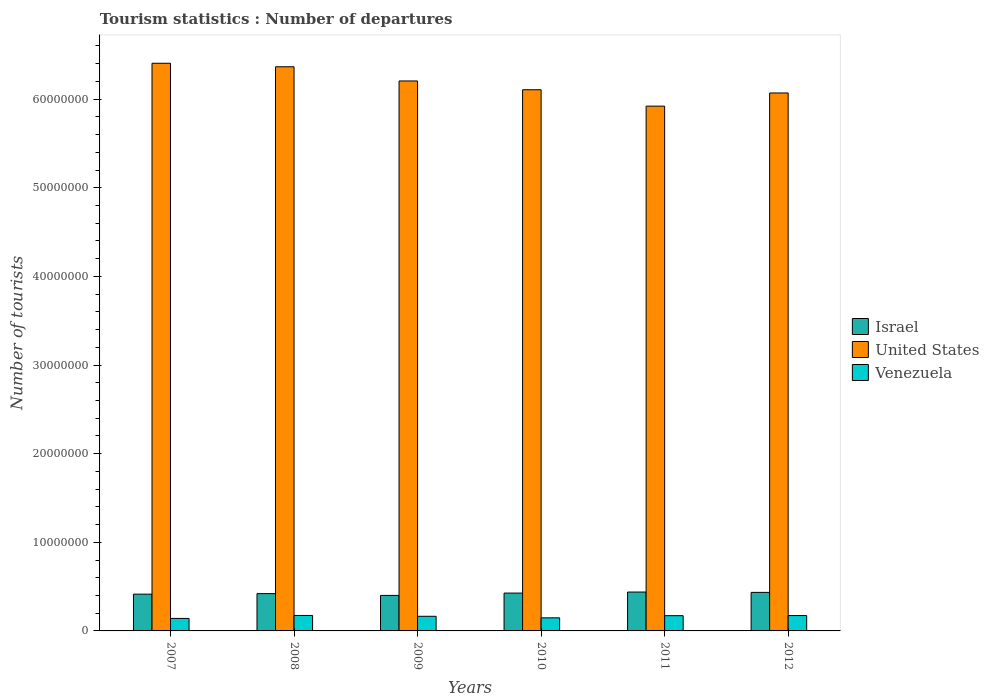How many different coloured bars are there?
Your answer should be compact. 3. Are the number of bars per tick equal to the number of legend labels?
Offer a terse response. Yes. Are the number of bars on each tick of the X-axis equal?
Your answer should be compact. Yes. How many bars are there on the 3rd tick from the right?
Your response must be concise. 3. What is the label of the 3rd group of bars from the left?
Keep it short and to the point. 2009. What is the number of tourist departures in Venezuela in 2009?
Provide a succinct answer. 1.65e+06. Across all years, what is the maximum number of tourist departures in Venezuela?
Offer a terse response. 1.74e+06. Across all years, what is the minimum number of tourist departures in Israel?
Keep it short and to the point. 4.01e+06. In which year was the number of tourist departures in United States minimum?
Offer a very short reply. 2011. What is the total number of tourist departures in United States in the graph?
Offer a terse response. 3.71e+08. What is the difference between the number of tourist departures in United States in 2007 and that in 2009?
Your answer should be very brief. 2.00e+06. What is the difference between the number of tourist departures in Israel in 2007 and the number of tourist departures in United States in 2009?
Offer a terse response. -5.79e+07. What is the average number of tourist departures in Israel per year?
Offer a terse response. 4.23e+06. In the year 2010, what is the difference between the number of tourist departures in Venezuela and number of tourist departures in United States?
Your answer should be compact. -5.96e+07. In how many years, is the number of tourist departures in Venezuela greater than 34000000?
Your answer should be compact. 0. What is the ratio of the number of tourist departures in Israel in 2009 to that in 2012?
Your answer should be very brief. 0.92. What is the difference between the highest and the second highest number of tourist departures in Venezuela?
Offer a very short reply. 1.10e+04. What is the difference between the highest and the lowest number of tourist departures in Israel?
Provide a short and direct response. 3.80e+05. Is the sum of the number of tourist departures in Israel in 2010 and 2012 greater than the maximum number of tourist departures in Venezuela across all years?
Provide a short and direct response. Yes. What does the 1st bar from the right in 2008 represents?
Give a very brief answer. Venezuela. Is it the case that in every year, the sum of the number of tourist departures in United States and number of tourist departures in Venezuela is greater than the number of tourist departures in Israel?
Give a very brief answer. Yes. How many bars are there?
Your response must be concise. 18. What is the difference between two consecutive major ticks on the Y-axis?
Ensure brevity in your answer.  1.00e+07. Are the values on the major ticks of Y-axis written in scientific E-notation?
Your answer should be very brief. No. Does the graph contain any zero values?
Provide a short and direct response. No. Does the graph contain grids?
Provide a short and direct response. No. Where does the legend appear in the graph?
Ensure brevity in your answer.  Center right. How are the legend labels stacked?
Keep it short and to the point. Vertical. What is the title of the graph?
Ensure brevity in your answer.  Tourism statistics : Number of departures. Does "Aruba" appear as one of the legend labels in the graph?
Ensure brevity in your answer.  No. What is the label or title of the X-axis?
Ensure brevity in your answer.  Years. What is the label or title of the Y-axis?
Offer a very short reply. Number of tourists. What is the Number of tourists in Israel in 2007?
Your answer should be compact. 4.15e+06. What is the Number of tourists of United States in 2007?
Make the answer very short. 6.40e+07. What is the Number of tourists of Venezuela in 2007?
Give a very brief answer. 1.41e+06. What is the Number of tourists of Israel in 2008?
Offer a terse response. 4.21e+06. What is the Number of tourists of United States in 2008?
Your answer should be very brief. 6.37e+07. What is the Number of tourists in Venezuela in 2008?
Offer a very short reply. 1.74e+06. What is the Number of tourists of Israel in 2009?
Provide a succinct answer. 4.01e+06. What is the Number of tourists of United States in 2009?
Provide a short and direct response. 6.21e+07. What is the Number of tourists in Venezuela in 2009?
Your answer should be compact. 1.65e+06. What is the Number of tourists in Israel in 2010?
Give a very brief answer. 4.27e+06. What is the Number of tourists in United States in 2010?
Provide a succinct answer. 6.11e+07. What is the Number of tourists of Venezuela in 2010?
Your response must be concise. 1.48e+06. What is the Number of tourists of Israel in 2011?
Provide a short and direct response. 4.39e+06. What is the Number of tourists of United States in 2011?
Provide a short and direct response. 5.92e+07. What is the Number of tourists of Venezuela in 2011?
Provide a succinct answer. 1.72e+06. What is the Number of tourists of Israel in 2012?
Provide a short and direct response. 4.35e+06. What is the Number of tourists of United States in 2012?
Your answer should be very brief. 6.07e+07. What is the Number of tourists of Venezuela in 2012?
Your response must be concise. 1.73e+06. Across all years, what is the maximum Number of tourists in Israel?
Keep it short and to the point. 4.39e+06. Across all years, what is the maximum Number of tourists of United States?
Your answer should be very brief. 6.40e+07. Across all years, what is the maximum Number of tourists of Venezuela?
Your response must be concise. 1.74e+06. Across all years, what is the minimum Number of tourists of Israel?
Give a very brief answer. 4.01e+06. Across all years, what is the minimum Number of tourists of United States?
Provide a succinct answer. 5.92e+07. Across all years, what is the minimum Number of tourists in Venezuela?
Ensure brevity in your answer.  1.41e+06. What is the total Number of tourists of Israel in the graph?
Keep it short and to the point. 2.54e+07. What is the total Number of tourists of United States in the graph?
Your answer should be compact. 3.71e+08. What is the total Number of tourists of Venezuela in the graph?
Keep it short and to the point. 9.74e+06. What is the difference between the Number of tourists in United States in 2007 and that in 2008?
Give a very brief answer. 3.96e+05. What is the difference between the Number of tourists in Venezuela in 2007 and that in 2008?
Your answer should be compact. -3.35e+05. What is the difference between the Number of tourists in Israel in 2007 and that in 2009?
Your answer should be very brief. 1.40e+05. What is the difference between the Number of tourists in United States in 2007 and that in 2009?
Provide a short and direct response. 2.00e+06. What is the difference between the Number of tourists of Venezuela in 2007 and that in 2009?
Make the answer very short. -2.41e+05. What is the difference between the Number of tourists of Israel in 2007 and that in 2010?
Give a very brief answer. -1.22e+05. What is the difference between the Number of tourists of United States in 2007 and that in 2010?
Ensure brevity in your answer.  2.99e+06. What is the difference between the Number of tourists in Venezuela in 2007 and that in 2010?
Provide a succinct answer. -6.70e+04. What is the difference between the Number of tourists in Israel in 2007 and that in 2011?
Offer a terse response. -2.40e+05. What is the difference between the Number of tourists in United States in 2007 and that in 2011?
Make the answer very short. 4.84e+06. What is the difference between the Number of tourists of Venezuela in 2007 and that in 2011?
Your answer should be very brief. -3.09e+05. What is the difference between the Number of tourists of Israel in 2007 and that in 2012?
Provide a short and direct response. -2.02e+05. What is the difference between the Number of tourists of United States in 2007 and that in 2012?
Your answer should be compact. 3.35e+06. What is the difference between the Number of tourists in Venezuela in 2007 and that in 2012?
Give a very brief answer. -3.24e+05. What is the difference between the Number of tourists in United States in 2008 and that in 2009?
Your answer should be compact. 1.60e+06. What is the difference between the Number of tourists in Venezuela in 2008 and that in 2009?
Keep it short and to the point. 9.40e+04. What is the difference between the Number of tourists in Israel in 2008 and that in 2010?
Offer a very short reply. -6.20e+04. What is the difference between the Number of tourists of United States in 2008 and that in 2010?
Provide a succinct answer. 2.59e+06. What is the difference between the Number of tourists in Venezuela in 2008 and that in 2010?
Offer a terse response. 2.68e+05. What is the difference between the Number of tourists in United States in 2008 and that in 2011?
Make the answer very short. 4.44e+06. What is the difference between the Number of tourists of Venezuela in 2008 and that in 2011?
Make the answer very short. 2.60e+04. What is the difference between the Number of tourists of Israel in 2008 and that in 2012?
Provide a succinct answer. -1.42e+05. What is the difference between the Number of tourists in United States in 2008 and that in 2012?
Offer a terse response. 2.96e+06. What is the difference between the Number of tourists of Venezuela in 2008 and that in 2012?
Make the answer very short. 1.10e+04. What is the difference between the Number of tourists of Israel in 2009 and that in 2010?
Ensure brevity in your answer.  -2.62e+05. What is the difference between the Number of tourists of United States in 2009 and that in 2010?
Provide a short and direct response. 9.90e+05. What is the difference between the Number of tourists of Venezuela in 2009 and that in 2010?
Your response must be concise. 1.74e+05. What is the difference between the Number of tourists of Israel in 2009 and that in 2011?
Offer a terse response. -3.80e+05. What is the difference between the Number of tourists in United States in 2009 and that in 2011?
Give a very brief answer. 2.84e+06. What is the difference between the Number of tourists in Venezuela in 2009 and that in 2011?
Make the answer very short. -6.80e+04. What is the difference between the Number of tourists of Israel in 2009 and that in 2012?
Provide a short and direct response. -3.42e+05. What is the difference between the Number of tourists of United States in 2009 and that in 2012?
Keep it short and to the point. 1.36e+06. What is the difference between the Number of tourists of Venezuela in 2009 and that in 2012?
Your response must be concise. -8.30e+04. What is the difference between the Number of tourists of Israel in 2010 and that in 2011?
Provide a short and direct response. -1.18e+05. What is the difference between the Number of tourists in United States in 2010 and that in 2011?
Provide a short and direct response. 1.85e+06. What is the difference between the Number of tourists in Venezuela in 2010 and that in 2011?
Make the answer very short. -2.42e+05. What is the difference between the Number of tourists of Israel in 2010 and that in 2012?
Your response must be concise. -8.00e+04. What is the difference between the Number of tourists of United States in 2010 and that in 2012?
Offer a terse response. 3.65e+05. What is the difference between the Number of tourists in Venezuela in 2010 and that in 2012?
Provide a succinct answer. -2.57e+05. What is the difference between the Number of tourists of Israel in 2011 and that in 2012?
Your answer should be very brief. 3.80e+04. What is the difference between the Number of tourists in United States in 2011 and that in 2012?
Provide a short and direct response. -1.49e+06. What is the difference between the Number of tourists in Venezuela in 2011 and that in 2012?
Your answer should be very brief. -1.50e+04. What is the difference between the Number of tourists in Israel in 2007 and the Number of tourists in United States in 2008?
Keep it short and to the point. -5.95e+07. What is the difference between the Number of tourists of Israel in 2007 and the Number of tourists of Venezuela in 2008?
Provide a short and direct response. 2.40e+06. What is the difference between the Number of tourists of United States in 2007 and the Number of tourists of Venezuela in 2008?
Keep it short and to the point. 6.23e+07. What is the difference between the Number of tourists in Israel in 2007 and the Number of tourists in United States in 2009?
Provide a short and direct response. -5.79e+07. What is the difference between the Number of tourists in Israel in 2007 and the Number of tourists in Venezuela in 2009?
Ensure brevity in your answer.  2.50e+06. What is the difference between the Number of tourists of United States in 2007 and the Number of tourists of Venezuela in 2009?
Offer a terse response. 6.24e+07. What is the difference between the Number of tourists in Israel in 2007 and the Number of tourists in United States in 2010?
Provide a succinct answer. -5.69e+07. What is the difference between the Number of tourists in Israel in 2007 and the Number of tourists in Venezuela in 2010?
Your answer should be very brief. 2.67e+06. What is the difference between the Number of tourists in United States in 2007 and the Number of tourists in Venezuela in 2010?
Make the answer very short. 6.26e+07. What is the difference between the Number of tourists in Israel in 2007 and the Number of tourists in United States in 2011?
Ensure brevity in your answer.  -5.51e+07. What is the difference between the Number of tourists in Israel in 2007 and the Number of tourists in Venezuela in 2011?
Your answer should be compact. 2.43e+06. What is the difference between the Number of tourists in United States in 2007 and the Number of tourists in Venezuela in 2011?
Offer a terse response. 6.23e+07. What is the difference between the Number of tourists in Israel in 2007 and the Number of tourists in United States in 2012?
Provide a short and direct response. -5.65e+07. What is the difference between the Number of tourists of Israel in 2007 and the Number of tourists of Venezuela in 2012?
Provide a short and direct response. 2.41e+06. What is the difference between the Number of tourists of United States in 2007 and the Number of tourists of Venezuela in 2012?
Ensure brevity in your answer.  6.23e+07. What is the difference between the Number of tourists of Israel in 2008 and the Number of tourists of United States in 2009?
Your response must be concise. -5.78e+07. What is the difference between the Number of tourists of Israel in 2008 and the Number of tourists of Venezuela in 2009?
Give a very brief answer. 2.56e+06. What is the difference between the Number of tourists of United States in 2008 and the Number of tourists of Venezuela in 2009?
Keep it short and to the point. 6.20e+07. What is the difference between the Number of tourists in Israel in 2008 and the Number of tourists in United States in 2010?
Provide a succinct answer. -5.69e+07. What is the difference between the Number of tourists in Israel in 2008 and the Number of tourists in Venezuela in 2010?
Your response must be concise. 2.73e+06. What is the difference between the Number of tourists of United States in 2008 and the Number of tourists of Venezuela in 2010?
Your answer should be compact. 6.22e+07. What is the difference between the Number of tourists of Israel in 2008 and the Number of tourists of United States in 2011?
Keep it short and to the point. -5.50e+07. What is the difference between the Number of tourists in Israel in 2008 and the Number of tourists in Venezuela in 2011?
Give a very brief answer. 2.49e+06. What is the difference between the Number of tourists of United States in 2008 and the Number of tourists of Venezuela in 2011?
Give a very brief answer. 6.19e+07. What is the difference between the Number of tourists in Israel in 2008 and the Number of tourists in United States in 2012?
Provide a short and direct response. -5.65e+07. What is the difference between the Number of tourists of Israel in 2008 and the Number of tourists of Venezuela in 2012?
Make the answer very short. 2.47e+06. What is the difference between the Number of tourists in United States in 2008 and the Number of tourists in Venezuela in 2012?
Keep it short and to the point. 6.19e+07. What is the difference between the Number of tourists in Israel in 2009 and the Number of tourists in United States in 2010?
Offer a very short reply. -5.71e+07. What is the difference between the Number of tourists in Israel in 2009 and the Number of tourists in Venezuela in 2010?
Ensure brevity in your answer.  2.53e+06. What is the difference between the Number of tourists in United States in 2009 and the Number of tourists in Venezuela in 2010?
Provide a short and direct response. 6.06e+07. What is the difference between the Number of tourists of Israel in 2009 and the Number of tourists of United States in 2011?
Make the answer very short. -5.52e+07. What is the difference between the Number of tourists of Israel in 2009 and the Number of tourists of Venezuela in 2011?
Make the answer very short. 2.29e+06. What is the difference between the Number of tourists of United States in 2009 and the Number of tourists of Venezuela in 2011?
Your response must be concise. 6.03e+07. What is the difference between the Number of tourists in Israel in 2009 and the Number of tourists in United States in 2012?
Give a very brief answer. -5.67e+07. What is the difference between the Number of tourists of Israel in 2009 and the Number of tourists of Venezuela in 2012?
Make the answer very short. 2.27e+06. What is the difference between the Number of tourists of United States in 2009 and the Number of tourists of Venezuela in 2012?
Offer a terse response. 6.03e+07. What is the difference between the Number of tourists in Israel in 2010 and the Number of tourists in United States in 2011?
Provide a short and direct response. -5.49e+07. What is the difference between the Number of tourists of Israel in 2010 and the Number of tourists of Venezuela in 2011?
Give a very brief answer. 2.55e+06. What is the difference between the Number of tourists of United States in 2010 and the Number of tourists of Venezuela in 2011?
Give a very brief answer. 5.93e+07. What is the difference between the Number of tourists in Israel in 2010 and the Number of tourists in United States in 2012?
Your answer should be very brief. -5.64e+07. What is the difference between the Number of tourists in Israel in 2010 and the Number of tourists in Venezuela in 2012?
Keep it short and to the point. 2.54e+06. What is the difference between the Number of tourists in United States in 2010 and the Number of tourists in Venezuela in 2012?
Provide a succinct answer. 5.93e+07. What is the difference between the Number of tourists of Israel in 2011 and the Number of tourists of United States in 2012?
Your answer should be very brief. -5.63e+07. What is the difference between the Number of tourists in Israel in 2011 and the Number of tourists in Venezuela in 2012?
Your answer should be very brief. 2.65e+06. What is the difference between the Number of tourists of United States in 2011 and the Number of tourists of Venezuela in 2012?
Provide a short and direct response. 5.75e+07. What is the average Number of tourists in Israel per year?
Your answer should be compact. 4.23e+06. What is the average Number of tourists of United States per year?
Your answer should be compact. 6.18e+07. What is the average Number of tourists in Venezuela per year?
Provide a succinct answer. 1.62e+06. In the year 2007, what is the difference between the Number of tourists in Israel and Number of tourists in United States?
Ensure brevity in your answer.  -5.99e+07. In the year 2007, what is the difference between the Number of tourists of Israel and Number of tourists of Venezuela?
Your answer should be compact. 2.74e+06. In the year 2007, what is the difference between the Number of tourists in United States and Number of tourists in Venezuela?
Make the answer very short. 6.26e+07. In the year 2008, what is the difference between the Number of tourists of Israel and Number of tourists of United States?
Your response must be concise. -5.94e+07. In the year 2008, what is the difference between the Number of tourists of Israel and Number of tourists of Venezuela?
Keep it short and to the point. 2.46e+06. In the year 2008, what is the difference between the Number of tourists of United States and Number of tourists of Venezuela?
Ensure brevity in your answer.  6.19e+07. In the year 2009, what is the difference between the Number of tourists of Israel and Number of tourists of United States?
Make the answer very short. -5.80e+07. In the year 2009, what is the difference between the Number of tourists of Israel and Number of tourists of Venezuela?
Give a very brief answer. 2.36e+06. In the year 2009, what is the difference between the Number of tourists in United States and Number of tourists in Venezuela?
Make the answer very short. 6.04e+07. In the year 2010, what is the difference between the Number of tourists in Israel and Number of tourists in United States?
Ensure brevity in your answer.  -5.68e+07. In the year 2010, what is the difference between the Number of tourists in Israel and Number of tourists in Venezuela?
Your response must be concise. 2.79e+06. In the year 2010, what is the difference between the Number of tourists in United States and Number of tourists in Venezuela?
Provide a succinct answer. 5.96e+07. In the year 2011, what is the difference between the Number of tourists of Israel and Number of tourists of United States?
Ensure brevity in your answer.  -5.48e+07. In the year 2011, what is the difference between the Number of tourists in Israel and Number of tourists in Venezuela?
Provide a short and direct response. 2.67e+06. In the year 2011, what is the difference between the Number of tourists of United States and Number of tourists of Venezuela?
Your answer should be very brief. 5.75e+07. In the year 2012, what is the difference between the Number of tourists of Israel and Number of tourists of United States?
Provide a succinct answer. -5.63e+07. In the year 2012, what is the difference between the Number of tourists in Israel and Number of tourists in Venezuela?
Your response must be concise. 2.62e+06. In the year 2012, what is the difference between the Number of tourists in United States and Number of tourists in Venezuela?
Provide a short and direct response. 5.90e+07. What is the ratio of the Number of tourists of Israel in 2007 to that in 2008?
Give a very brief answer. 0.99. What is the ratio of the Number of tourists of United States in 2007 to that in 2008?
Keep it short and to the point. 1.01. What is the ratio of the Number of tourists of Venezuela in 2007 to that in 2008?
Provide a succinct answer. 0.81. What is the ratio of the Number of tourists of Israel in 2007 to that in 2009?
Your answer should be very brief. 1.03. What is the ratio of the Number of tourists of United States in 2007 to that in 2009?
Your answer should be very brief. 1.03. What is the ratio of the Number of tourists in Venezuela in 2007 to that in 2009?
Your answer should be compact. 0.85. What is the ratio of the Number of tourists in Israel in 2007 to that in 2010?
Offer a terse response. 0.97. What is the ratio of the Number of tourists in United States in 2007 to that in 2010?
Keep it short and to the point. 1.05. What is the ratio of the Number of tourists in Venezuela in 2007 to that in 2010?
Provide a short and direct response. 0.95. What is the ratio of the Number of tourists of Israel in 2007 to that in 2011?
Offer a very short reply. 0.95. What is the ratio of the Number of tourists of United States in 2007 to that in 2011?
Provide a succinct answer. 1.08. What is the ratio of the Number of tourists in Venezuela in 2007 to that in 2011?
Your response must be concise. 0.82. What is the ratio of the Number of tourists of Israel in 2007 to that in 2012?
Offer a very short reply. 0.95. What is the ratio of the Number of tourists in United States in 2007 to that in 2012?
Give a very brief answer. 1.06. What is the ratio of the Number of tourists in Venezuela in 2007 to that in 2012?
Keep it short and to the point. 0.81. What is the ratio of the Number of tourists of Israel in 2008 to that in 2009?
Offer a very short reply. 1.05. What is the ratio of the Number of tourists of United States in 2008 to that in 2009?
Provide a short and direct response. 1.03. What is the ratio of the Number of tourists in Venezuela in 2008 to that in 2009?
Keep it short and to the point. 1.06. What is the ratio of the Number of tourists of Israel in 2008 to that in 2010?
Offer a terse response. 0.99. What is the ratio of the Number of tourists of United States in 2008 to that in 2010?
Keep it short and to the point. 1.04. What is the ratio of the Number of tourists of Venezuela in 2008 to that in 2010?
Your response must be concise. 1.18. What is the ratio of the Number of tourists in Israel in 2008 to that in 2011?
Keep it short and to the point. 0.96. What is the ratio of the Number of tourists in United States in 2008 to that in 2011?
Your answer should be very brief. 1.08. What is the ratio of the Number of tourists of Venezuela in 2008 to that in 2011?
Provide a short and direct response. 1.02. What is the ratio of the Number of tourists in Israel in 2008 to that in 2012?
Offer a terse response. 0.97. What is the ratio of the Number of tourists of United States in 2008 to that in 2012?
Provide a succinct answer. 1.05. What is the ratio of the Number of tourists in Venezuela in 2008 to that in 2012?
Provide a succinct answer. 1.01. What is the ratio of the Number of tourists of Israel in 2009 to that in 2010?
Give a very brief answer. 0.94. What is the ratio of the Number of tourists of United States in 2009 to that in 2010?
Make the answer very short. 1.02. What is the ratio of the Number of tourists in Venezuela in 2009 to that in 2010?
Your response must be concise. 1.12. What is the ratio of the Number of tourists of Israel in 2009 to that in 2011?
Give a very brief answer. 0.91. What is the ratio of the Number of tourists in United States in 2009 to that in 2011?
Make the answer very short. 1.05. What is the ratio of the Number of tourists in Venezuela in 2009 to that in 2011?
Provide a succinct answer. 0.96. What is the ratio of the Number of tourists in Israel in 2009 to that in 2012?
Keep it short and to the point. 0.92. What is the ratio of the Number of tourists in United States in 2009 to that in 2012?
Your response must be concise. 1.02. What is the ratio of the Number of tourists in Venezuela in 2009 to that in 2012?
Keep it short and to the point. 0.95. What is the ratio of the Number of tourists of Israel in 2010 to that in 2011?
Provide a short and direct response. 0.97. What is the ratio of the Number of tourists in United States in 2010 to that in 2011?
Offer a very short reply. 1.03. What is the ratio of the Number of tourists of Venezuela in 2010 to that in 2011?
Your answer should be compact. 0.86. What is the ratio of the Number of tourists in Israel in 2010 to that in 2012?
Provide a short and direct response. 0.98. What is the ratio of the Number of tourists in United States in 2010 to that in 2012?
Provide a succinct answer. 1.01. What is the ratio of the Number of tourists of Venezuela in 2010 to that in 2012?
Your answer should be very brief. 0.85. What is the ratio of the Number of tourists in Israel in 2011 to that in 2012?
Ensure brevity in your answer.  1.01. What is the ratio of the Number of tourists of United States in 2011 to that in 2012?
Offer a very short reply. 0.98. What is the difference between the highest and the second highest Number of tourists of Israel?
Make the answer very short. 3.80e+04. What is the difference between the highest and the second highest Number of tourists in United States?
Keep it short and to the point. 3.96e+05. What is the difference between the highest and the second highest Number of tourists in Venezuela?
Provide a short and direct response. 1.10e+04. What is the difference between the highest and the lowest Number of tourists in United States?
Make the answer very short. 4.84e+06. What is the difference between the highest and the lowest Number of tourists of Venezuela?
Ensure brevity in your answer.  3.35e+05. 